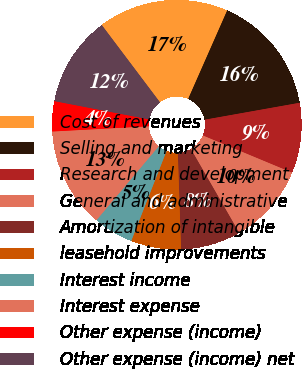<chart> <loc_0><loc_0><loc_500><loc_500><pie_chart><fcel>Cost of revenues<fcel>Selling and marketing<fcel>Research and development<fcel>General and administrative<fcel>Amortization of intangible<fcel>leasehold improvements<fcel>Interest income<fcel>Interest expense<fcel>Other expense (income)<fcel>Other expense (income) net<nl><fcel>16.88%<fcel>15.58%<fcel>9.09%<fcel>10.39%<fcel>7.79%<fcel>6.49%<fcel>5.19%<fcel>12.99%<fcel>3.9%<fcel>11.69%<nl></chart> 